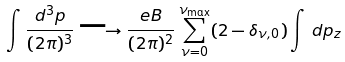Convert formula to latex. <formula><loc_0><loc_0><loc_500><loc_500>\int \frac { d ^ { 3 } p } { ( 2 \pi ) ^ { 3 } } \longrightarrow \frac { e B } { ( 2 \pi ) ^ { 2 } } \sum _ { \nu = 0 } ^ { \nu _ { \max } } ( 2 - \delta _ { \nu , 0 } ) \int \, d p _ { z }</formula> 